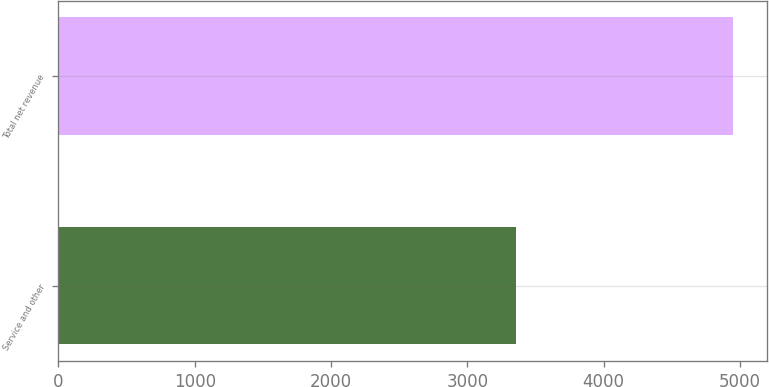Convert chart to OTSL. <chart><loc_0><loc_0><loc_500><loc_500><bar_chart><fcel>Service and other<fcel>Total net revenue<nl><fcel>3357<fcel>4950<nl></chart> 